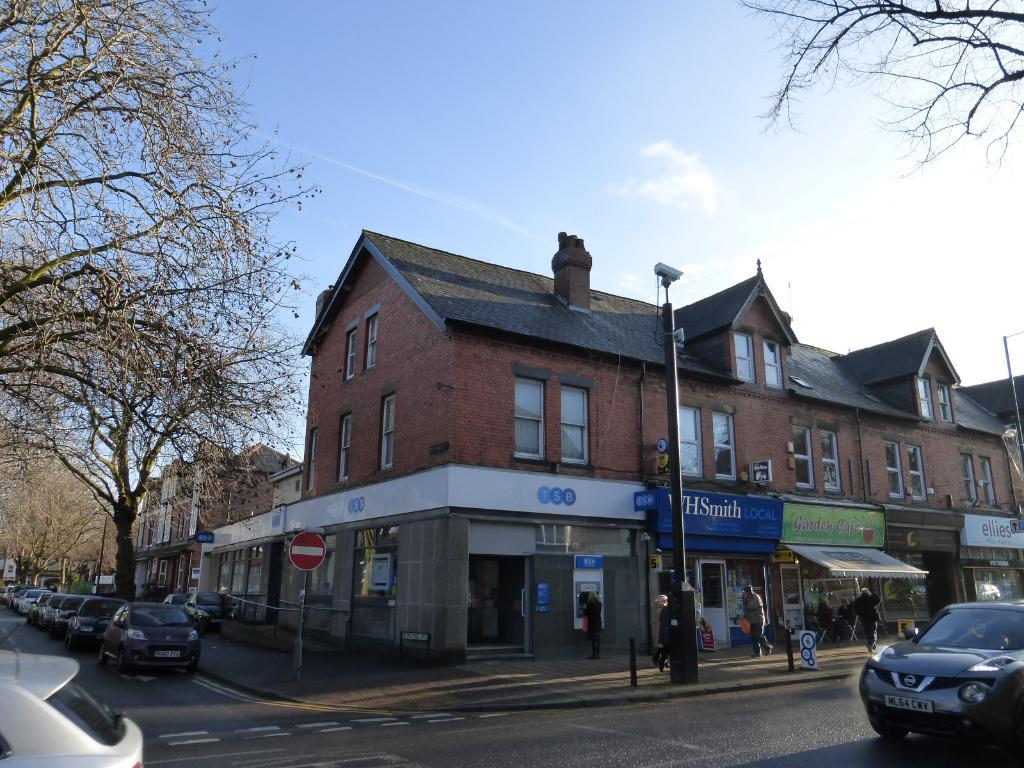What type of structures can be seen in the image? There are buildings in the image. What else is present in the image besides buildings? There are vehicles, poles, name boards, sign boards, and dried trees visible in the image. Can you describe the vehicles in the image? The specific type of vehicles is not mentioned, but they are present in the image. What is visible in the background of the image? The sky is visible in the background of the image. How does the root of the dried tree help the vehicles in the image? There are no roots mentioned in the image, and the dried trees are not interacting with the vehicles. 